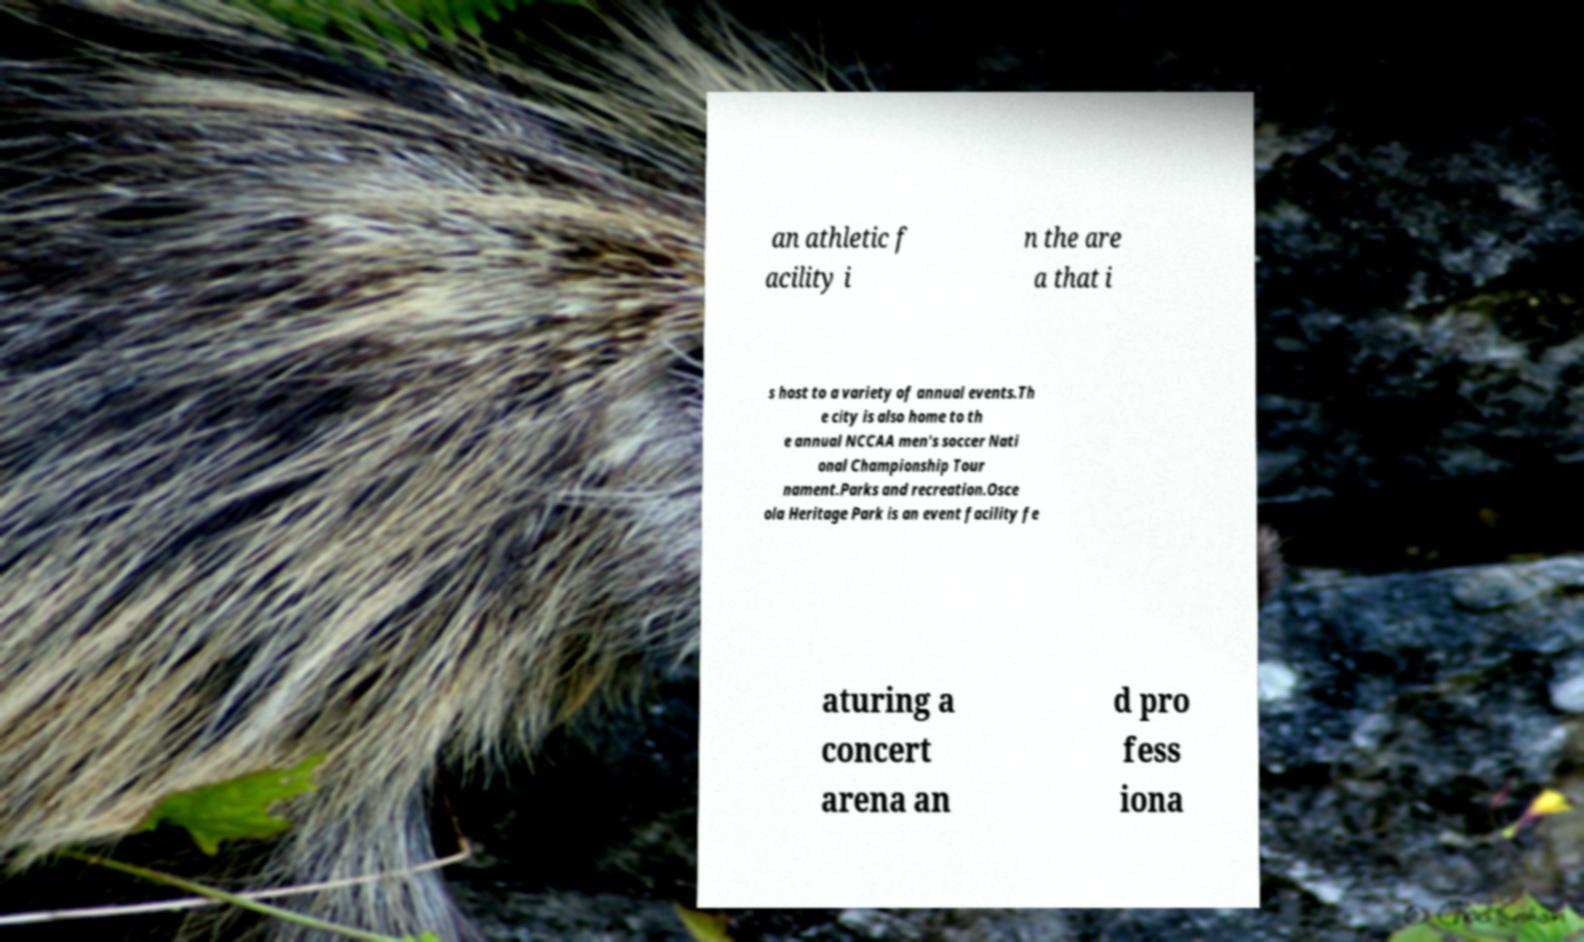Could you assist in decoding the text presented in this image and type it out clearly? an athletic f acility i n the are a that i s host to a variety of annual events.Th e city is also home to th e annual NCCAA men's soccer Nati onal Championship Tour nament.Parks and recreation.Osce ola Heritage Park is an event facility fe aturing a concert arena an d pro fess iona 